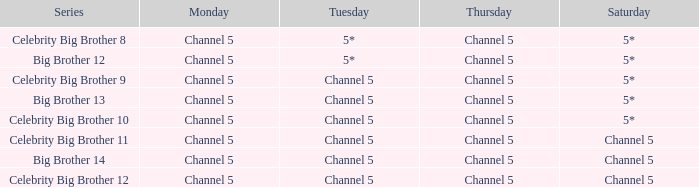Which series airs Saturday on Channel 5? Celebrity Big Brother 11, Big Brother 14, Celebrity Big Brother 12. 